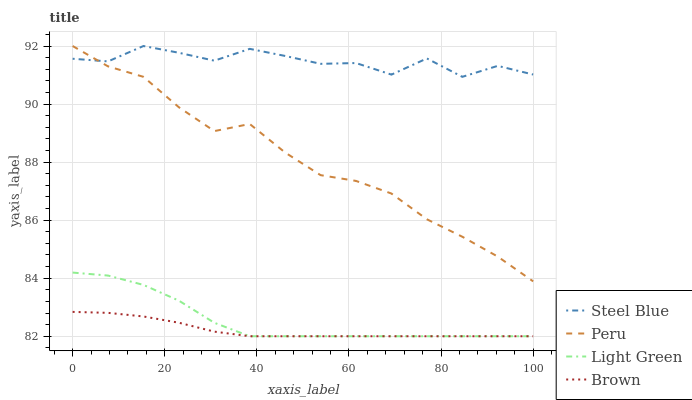Does Brown have the minimum area under the curve?
Answer yes or no. Yes. Does Steel Blue have the maximum area under the curve?
Answer yes or no. Yes. Does Light Green have the minimum area under the curve?
Answer yes or no. No. Does Light Green have the maximum area under the curve?
Answer yes or no. No. Is Brown the smoothest?
Answer yes or no. Yes. Is Steel Blue the roughest?
Answer yes or no. Yes. Is Light Green the smoothest?
Answer yes or no. No. Is Light Green the roughest?
Answer yes or no. No. Does Steel Blue have the lowest value?
Answer yes or no. No. Does Light Green have the highest value?
Answer yes or no. No. Is Light Green less than Steel Blue?
Answer yes or no. Yes. Is Steel Blue greater than Light Green?
Answer yes or no. Yes. Does Light Green intersect Steel Blue?
Answer yes or no. No. 